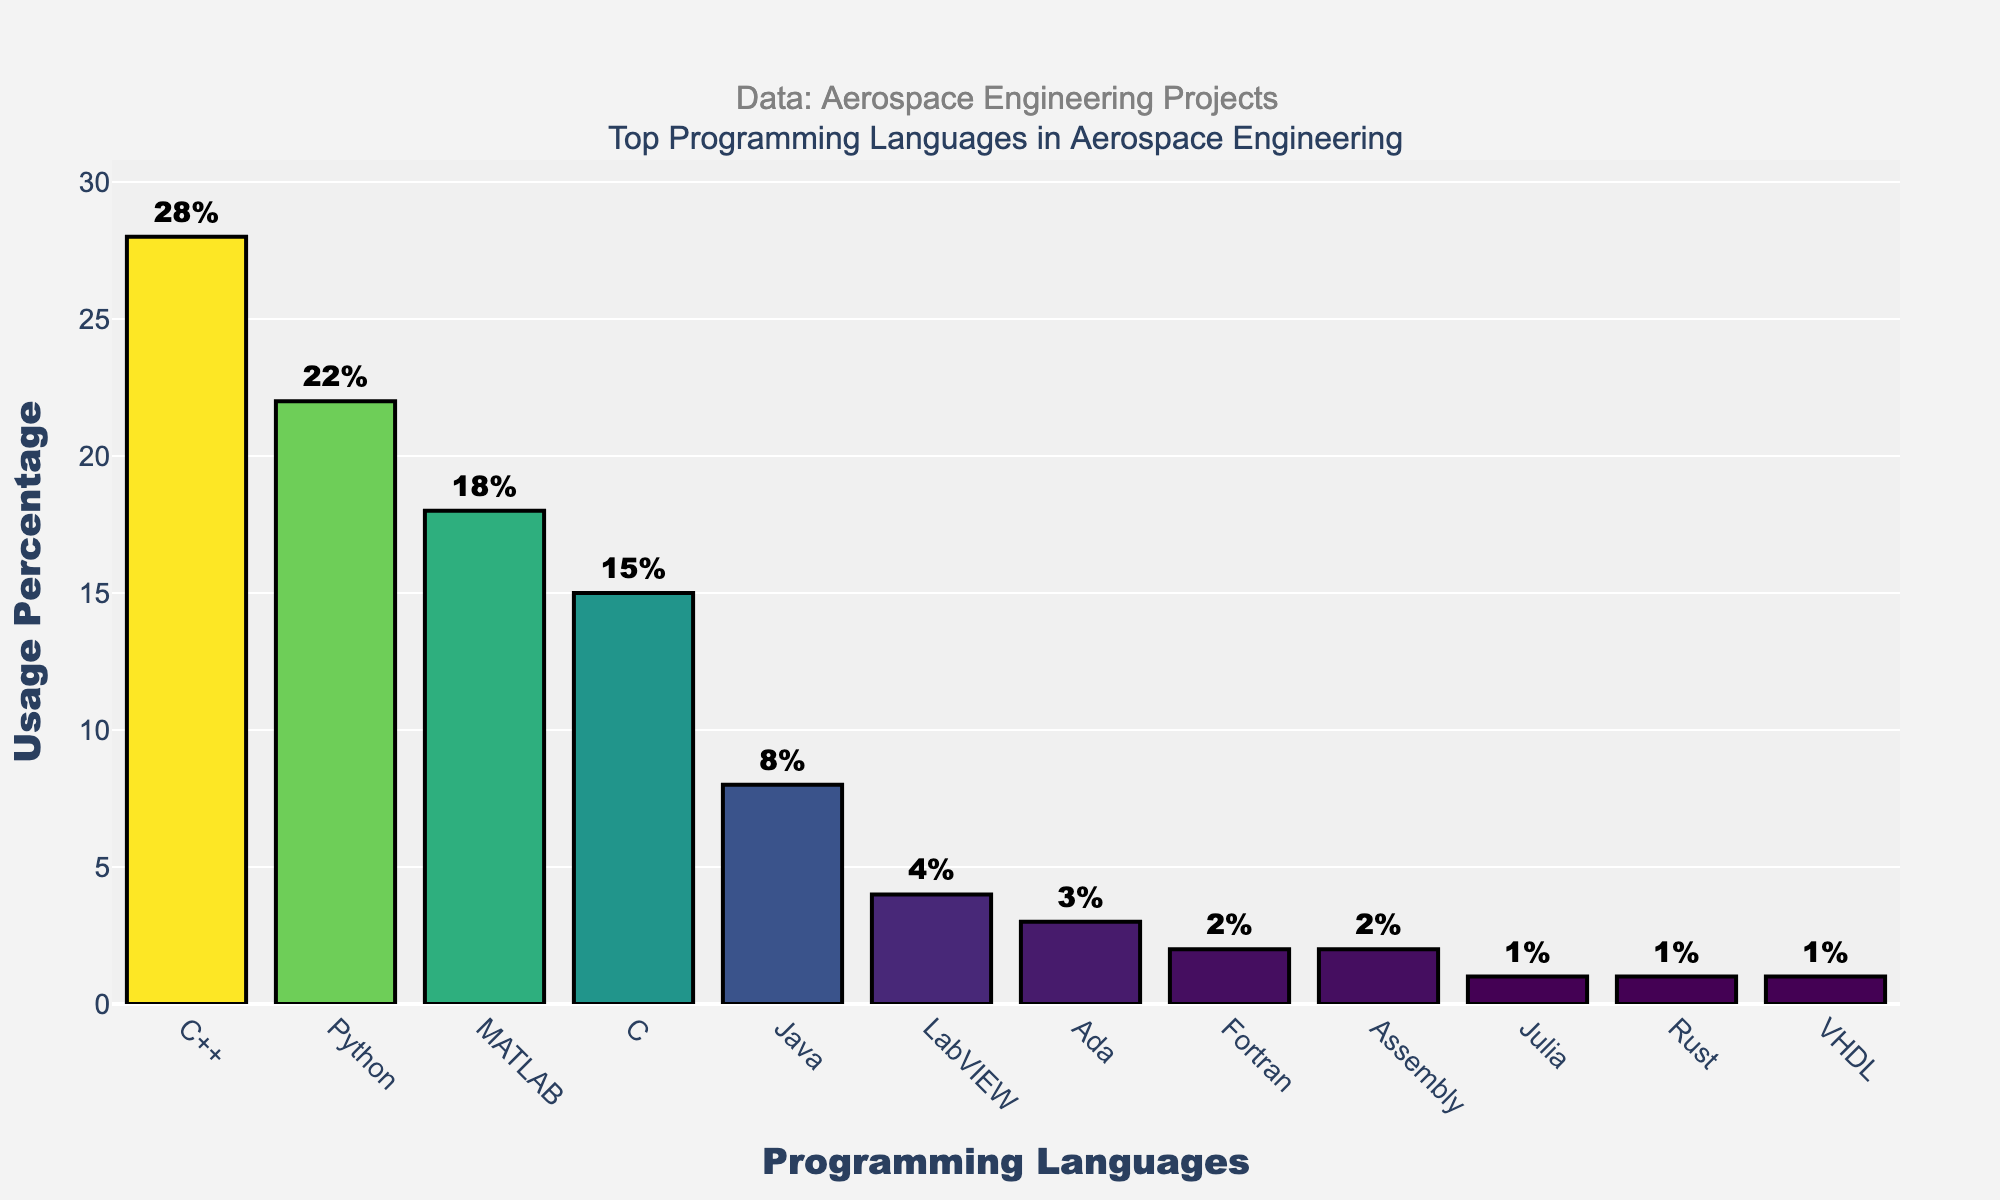Which programming language is the most used in aerospace engineering projects? The highest bar on the chart represents the most used programming language. Here, it's C++ with a usage percentage of 28%.
Answer: C++ What is the difference in usage percentage between C++ and Python? The height of the bars corresponds to usage percentage. C++ has 28%, and Python has 22%. The difference is 28% - 22% = 6%.
Answer: 6% Which language has a usage percentage just above MATLAB? The languages are sorted in descending order. MATLAB has 18%. The language just above MATLAB is Python with 22%.
Answer: Python How many languages have a usage percentage lower than 5%? The languages with bars lower than 5% are LabVIEW, Ada, Fortran, Assembly, Julia, Rust, and VHDL. Count them to get 7 languages.
Answer: 7 What is the total usage percentage of the least popular three languages? The least popular languages are Julia (1%), Rust (1%), and VHDL (1%). Sum their percentages: 1% + 1% + 1% = 3%.
Answer: 3% Which language has a usage percentage closest but not equal to 15%? The chart shows that C has a usage percentage of exactly 15%, and Java has the next closest percentage at 8%.
Answer: Java What is the combined usage percentage of C++ and MATLAB? The usage percentages of C++ and MATLAB are 28% and 18%, respectively. Sum them: 28% + 18% = 46%.
Answer: 46% Is Python used more or less frequently than Java and C combined? Python usage is 22%. Java is 8% and C is 15%. Combined, Java and C have a usage of 8% + 15% = 23%. 22% (Python) is less than 23% (Java and C combined).
Answer: Less What visual attribute represents the usage percentage in the bar chart? The height of the bars correlates with the usage percentages, indicating the popularity of each language.
Answer: Height How much more popular is C++ than LabVIEW? C++ has a usage percentage of 28%, while LabVIEW has 4%. The difference is 28% - 4% = 24%.
Answer: 24% 